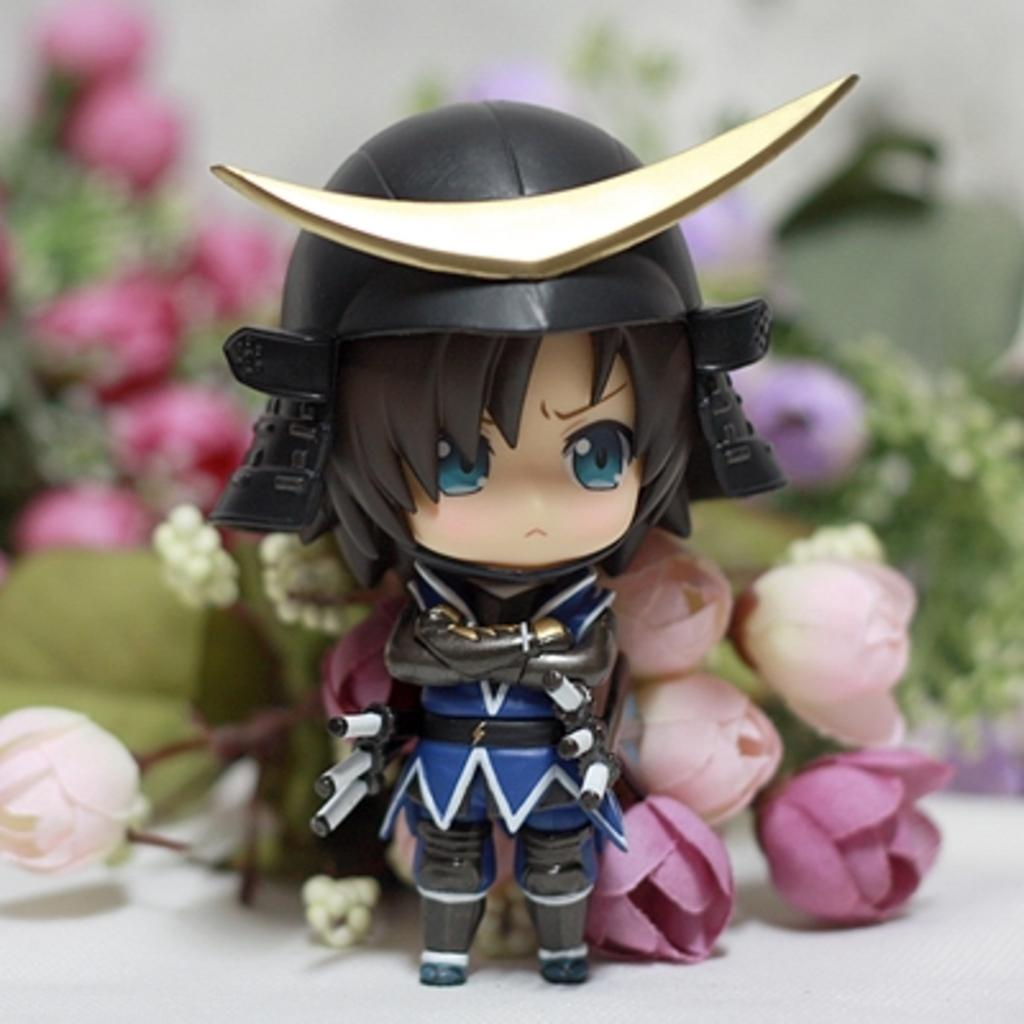What object can be seen in the image? There is a toy in the image. Where is the toy located? The toy is on a surface. What can be seen in the background of the image? There are flowers visible in the background of the image. What time does the clock show in the image? There is no clock present in the image, so it is not possible to determine the time. 